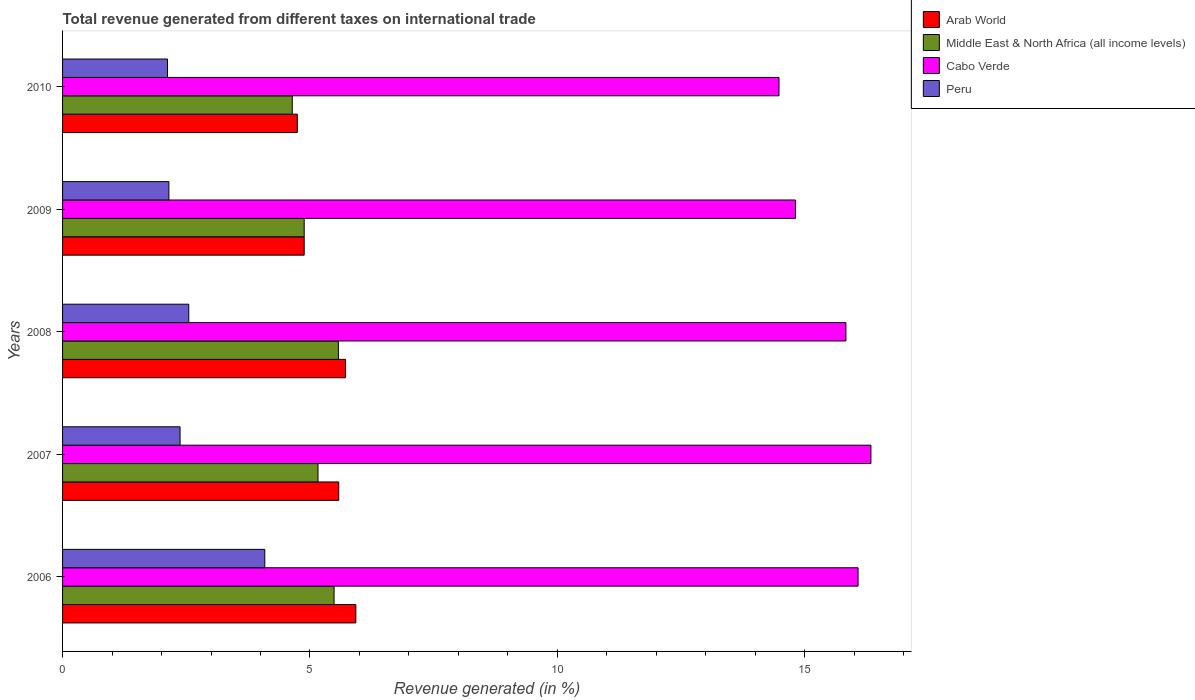Are the number of bars on each tick of the Y-axis equal?
Make the answer very short. Yes. How many bars are there on the 1st tick from the top?
Give a very brief answer. 4. In how many cases, is the number of bars for a given year not equal to the number of legend labels?
Offer a very short reply. 0. What is the total revenue generated in Middle East & North Africa (all income levels) in 2009?
Your response must be concise. 4.88. Across all years, what is the maximum total revenue generated in Arab World?
Your answer should be very brief. 5.93. Across all years, what is the minimum total revenue generated in Middle East & North Africa (all income levels)?
Your answer should be very brief. 4.64. What is the total total revenue generated in Arab World in the graph?
Your response must be concise. 26.86. What is the difference between the total revenue generated in Middle East & North Africa (all income levels) in 2006 and that in 2007?
Provide a succinct answer. 0.32. What is the difference between the total revenue generated in Arab World in 2006 and the total revenue generated in Cabo Verde in 2007?
Give a very brief answer. -10.41. What is the average total revenue generated in Middle East & North Africa (all income levels) per year?
Ensure brevity in your answer.  5.15. In the year 2008, what is the difference between the total revenue generated in Arab World and total revenue generated in Peru?
Offer a terse response. 3.17. In how many years, is the total revenue generated in Peru greater than 5 %?
Your answer should be very brief. 0. What is the ratio of the total revenue generated in Peru in 2006 to that in 2009?
Give a very brief answer. 1.9. Is the total revenue generated in Cabo Verde in 2006 less than that in 2008?
Offer a very short reply. No. What is the difference between the highest and the second highest total revenue generated in Middle East & North Africa (all income levels)?
Provide a short and direct response. 0.09. What is the difference between the highest and the lowest total revenue generated in Peru?
Ensure brevity in your answer.  1.97. In how many years, is the total revenue generated in Middle East & North Africa (all income levels) greater than the average total revenue generated in Middle East & North Africa (all income levels) taken over all years?
Give a very brief answer. 3. What does the 3rd bar from the top in 2007 represents?
Ensure brevity in your answer.  Middle East & North Africa (all income levels). What does the 4th bar from the bottom in 2009 represents?
Offer a terse response. Peru. How many bars are there?
Offer a terse response. 20. Are all the bars in the graph horizontal?
Give a very brief answer. Yes. What is the difference between two consecutive major ticks on the X-axis?
Ensure brevity in your answer.  5. Does the graph contain any zero values?
Offer a terse response. No. Where does the legend appear in the graph?
Your response must be concise. Top right. What is the title of the graph?
Ensure brevity in your answer.  Total revenue generated from different taxes on international trade. Does "Turkey" appear as one of the legend labels in the graph?
Keep it short and to the point. No. What is the label or title of the X-axis?
Provide a short and direct response. Revenue generated (in %). What is the label or title of the Y-axis?
Your answer should be compact. Years. What is the Revenue generated (in %) of Arab World in 2006?
Offer a terse response. 5.93. What is the Revenue generated (in %) of Middle East & North Africa (all income levels) in 2006?
Offer a terse response. 5.49. What is the Revenue generated (in %) of Cabo Verde in 2006?
Provide a succinct answer. 16.08. What is the Revenue generated (in %) of Peru in 2006?
Offer a very short reply. 4.09. What is the Revenue generated (in %) of Arab World in 2007?
Offer a very short reply. 5.58. What is the Revenue generated (in %) of Middle East & North Africa (all income levels) in 2007?
Your response must be concise. 5.16. What is the Revenue generated (in %) in Cabo Verde in 2007?
Provide a succinct answer. 16.34. What is the Revenue generated (in %) of Peru in 2007?
Your answer should be very brief. 2.37. What is the Revenue generated (in %) in Arab World in 2008?
Ensure brevity in your answer.  5.72. What is the Revenue generated (in %) in Middle East & North Africa (all income levels) in 2008?
Your answer should be compact. 5.58. What is the Revenue generated (in %) of Cabo Verde in 2008?
Your response must be concise. 15.83. What is the Revenue generated (in %) of Peru in 2008?
Provide a short and direct response. 2.55. What is the Revenue generated (in %) in Arab World in 2009?
Your answer should be compact. 4.88. What is the Revenue generated (in %) of Middle East & North Africa (all income levels) in 2009?
Provide a short and direct response. 4.88. What is the Revenue generated (in %) of Cabo Verde in 2009?
Provide a short and direct response. 14.81. What is the Revenue generated (in %) of Peru in 2009?
Make the answer very short. 2.15. What is the Revenue generated (in %) of Arab World in 2010?
Keep it short and to the point. 4.74. What is the Revenue generated (in %) in Middle East & North Africa (all income levels) in 2010?
Your answer should be very brief. 4.64. What is the Revenue generated (in %) of Cabo Verde in 2010?
Your response must be concise. 14.48. What is the Revenue generated (in %) of Peru in 2010?
Ensure brevity in your answer.  2.12. Across all years, what is the maximum Revenue generated (in %) of Arab World?
Provide a succinct answer. 5.93. Across all years, what is the maximum Revenue generated (in %) in Middle East & North Africa (all income levels)?
Provide a succinct answer. 5.58. Across all years, what is the maximum Revenue generated (in %) of Cabo Verde?
Keep it short and to the point. 16.34. Across all years, what is the maximum Revenue generated (in %) of Peru?
Provide a short and direct response. 4.09. Across all years, what is the minimum Revenue generated (in %) in Arab World?
Offer a very short reply. 4.74. Across all years, what is the minimum Revenue generated (in %) of Middle East & North Africa (all income levels)?
Provide a succinct answer. 4.64. Across all years, what is the minimum Revenue generated (in %) in Cabo Verde?
Give a very brief answer. 14.48. Across all years, what is the minimum Revenue generated (in %) in Peru?
Offer a very short reply. 2.12. What is the total Revenue generated (in %) in Arab World in the graph?
Provide a short and direct response. 26.86. What is the total Revenue generated (in %) in Middle East & North Africa (all income levels) in the graph?
Offer a very short reply. 25.75. What is the total Revenue generated (in %) of Cabo Verde in the graph?
Your response must be concise. 77.54. What is the total Revenue generated (in %) of Peru in the graph?
Keep it short and to the point. 13.28. What is the difference between the Revenue generated (in %) in Arab World in 2006 and that in 2007?
Your answer should be compact. 0.35. What is the difference between the Revenue generated (in %) of Middle East & North Africa (all income levels) in 2006 and that in 2007?
Keep it short and to the point. 0.32. What is the difference between the Revenue generated (in %) in Cabo Verde in 2006 and that in 2007?
Provide a succinct answer. -0.26. What is the difference between the Revenue generated (in %) in Peru in 2006 and that in 2007?
Make the answer very short. 1.71. What is the difference between the Revenue generated (in %) in Arab World in 2006 and that in 2008?
Offer a terse response. 0.21. What is the difference between the Revenue generated (in %) of Middle East & North Africa (all income levels) in 2006 and that in 2008?
Offer a very short reply. -0.09. What is the difference between the Revenue generated (in %) of Cabo Verde in 2006 and that in 2008?
Your answer should be very brief. 0.25. What is the difference between the Revenue generated (in %) in Peru in 2006 and that in 2008?
Offer a very short reply. 1.54. What is the difference between the Revenue generated (in %) of Arab World in 2006 and that in 2009?
Provide a short and direct response. 1.04. What is the difference between the Revenue generated (in %) of Middle East & North Africa (all income levels) in 2006 and that in 2009?
Ensure brevity in your answer.  0.6. What is the difference between the Revenue generated (in %) in Cabo Verde in 2006 and that in 2009?
Your response must be concise. 1.26. What is the difference between the Revenue generated (in %) of Peru in 2006 and that in 2009?
Your response must be concise. 1.94. What is the difference between the Revenue generated (in %) of Arab World in 2006 and that in 2010?
Ensure brevity in your answer.  1.18. What is the difference between the Revenue generated (in %) of Middle East & North Africa (all income levels) in 2006 and that in 2010?
Offer a very short reply. 0.84. What is the difference between the Revenue generated (in %) in Cabo Verde in 2006 and that in 2010?
Your answer should be very brief. 1.6. What is the difference between the Revenue generated (in %) of Peru in 2006 and that in 2010?
Provide a succinct answer. 1.97. What is the difference between the Revenue generated (in %) of Arab World in 2007 and that in 2008?
Your answer should be compact. -0.14. What is the difference between the Revenue generated (in %) in Middle East & North Africa (all income levels) in 2007 and that in 2008?
Offer a very short reply. -0.41. What is the difference between the Revenue generated (in %) of Cabo Verde in 2007 and that in 2008?
Offer a terse response. 0.51. What is the difference between the Revenue generated (in %) in Peru in 2007 and that in 2008?
Offer a very short reply. -0.18. What is the difference between the Revenue generated (in %) of Arab World in 2007 and that in 2009?
Your answer should be very brief. 0.7. What is the difference between the Revenue generated (in %) of Middle East & North Africa (all income levels) in 2007 and that in 2009?
Give a very brief answer. 0.28. What is the difference between the Revenue generated (in %) of Cabo Verde in 2007 and that in 2009?
Give a very brief answer. 1.52. What is the difference between the Revenue generated (in %) in Peru in 2007 and that in 2009?
Make the answer very short. 0.23. What is the difference between the Revenue generated (in %) in Arab World in 2007 and that in 2010?
Your answer should be very brief. 0.84. What is the difference between the Revenue generated (in %) in Middle East & North Africa (all income levels) in 2007 and that in 2010?
Give a very brief answer. 0.52. What is the difference between the Revenue generated (in %) in Cabo Verde in 2007 and that in 2010?
Give a very brief answer. 1.86. What is the difference between the Revenue generated (in %) in Peru in 2007 and that in 2010?
Ensure brevity in your answer.  0.25. What is the difference between the Revenue generated (in %) in Arab World in 2008 and that in 2009?
Ensure brevity in your answer.  0.84. What is the difference between the Revenue generated (in %) of Middle East & North Africa (all income levels) in 2008 and that in 2009?
Your answer should be very brief. 0.69. What is the difference between the Revenue generated (in %) in Cabo Verde in 2008 and that in 2009?
Provide a short and direct response. 1.02. What is the difference between the Revenue generated (in %) of Peru in 2008 and that in 2009?
Your response must be concise. 0.4. What is the difference between the Revenue generated (in %) of Arab World in 2008 and that in 2010?
Your answer should be very brief. 0.97. What is the difference between the Revenue generated (in %) of Middle East & North Africa (all income levels) in 2008 and that in 2010?
Give a very brief answer. 0.93. What is the difference between the Revenue generated (in %) in Cabo Verde in 2008 and that in 2010?
Provide a short and direct response. 1.35. What is the difference between the Revenue generated (in %) of Peru in 2008 and that in 2010?
Keep it short and to the point. 0.43. What is the difference between the Revenue generated (in %) of Arab World in 2009 and that in 2010?
Provide a short and direct response. 0.14. What is the difference between the Revenue generated (in %) in Middle East & North Africa (all income levels) in 2009 and that in 2010?
Ensure brevity in your answer.  0.24. What is the difference between the Revenue generated (in %) in Cabo Verde in 2009 and that in 2010?
Give a very brief answer. 0.33. What is the difference between the Revenue generated (in %) of Peru in 2009 and that in 2010?
Provide a succinct answer. 0.03. What is the difference between the Revenue generated (in %) in Arab World in 2006 and the Revenue generated (in %) in Middle East & North Africa (all income levels) in 2007?
Provide a short and direct response. 0.77. What is the difference between the Revenue generated (in %) in Arab World in 2006 and the Revenue generated (in %) in Cabo Verde in 2007?
Make the answer very short. -10.41. What is the difference between the Revenue generated (in %) in Arab World in 2006 and the Revenue generated (in %) in Peru in 2007?
Keep it short and to the point. 3.55. What is the difference between the Revenue generated (in %) in Middle East & North Africa (all income levels) in 2006 and the Revenue generated (in %) in Cabo Verde in 2007?
Give a very brief answer. -10.85. What is the difference between the Revenue generated (in %) of Middle East & North Africa (all income levels) in 2006 and the Revenue generated (in %) of Peru in 2007?
Your answer should be very brief. 3.11. What is the difference between the Revenue generated (in %) of Cabo Verde in 2006 and the Revenue generated (in %) of Peru in 2007?
Your response must be concise. 13.7. What is the difference between the Revenue generated (in %) in Arab World in 2006 and the Revenue generated (in %) in Middle East & North Africa (all income levels) in 2008?
Your answer should be compact. 0.35. What is the difference between the Revenue generated (in %) of Arab World in 2006 and the Revenue generated (in %) of Cabo Verde in 2008?
Give a very brief answer. -9.9. What is the difference between the Revenue generated (in %) in Arab World in 2006 and the Revenue generated (in %) in Peru in 2008?
Offer a terse response. 3.38. What is the difference between the Revenue generated (in %) of Middle East & North Africa (all income levels) in 2006 and the Revenue generated (in %) of Cabo Verde in 2008?
Your answer should be compact. -10.35. What is the difference between the Revenue generated (in %) in Middle East & North Africa (all income levels) in 2006 and the Revenue generated (in %) in Peru in 2008?
Provide a short and direct response. 2.94. What is the difference between the Revenue generated (in %) in Cabo Verde in 2006 and the Revenue generated (in %) in Peru in 2008?
Your response must be concise. 13.53. What is the difference between the Revenue generated (in %) of Arab World in 2006 and the Revenue generated (in %) of Middle East & North Africa (all income levels) in 2009?
Your answer should be compact. 1.04. What is the difference between the Revenue generated (in %) in Arab World in 2006 and the Revenue generated (in %) in Cabo Verde in 2009?
Your answer should be very brief. -8.89. What is the difference between the Revenue generated (in %) of Arab World in 2006 and the Revenue generated (in %) of Peru in 2009?
Offer a terse response. 3.78. What is the difference between the Revenue generated (in %) in Middle East & North Africa (all income levels) in 2006 and the Revenue generated (in %) in Cabo Verde in 2009?
Your response must be concise. -9.33. What is the difference between the Revenue generated (in %) of Middle East & North Africa (all income levels) in 2006 and the Revenue generated (in %) of Peru in 2009?
Make the answer very short. 3.34. What is the difference between the Revenue generated (in %) of Cabo Verde in 2006 and the Revenue generated (in %) of Peru in 2009?
Make the answer very short. 13.93. What is the difference between the Revenue generated (in %) of Arab World in 2006 and the Revenue generated (in %) of Middle East & North Africa (all income levels) in 2010?
Ensure brevity in your answer.  1.28. What is the difference between the Revenue generated (in %) in Arab World in 2006 and the Revenue generated (in %) in Cabo Verde in 2010?
Your answer should be very brief. -8.55. What is the difference between the Revenue generated (in %) in Arab World in 2006 and the Revenue generated (in %) in Peru in 2010?
Keep it short and to the point. 3.81. What is the difference between the Revenue generated (in %) of Middle East & North Africa (all income levels) in 2006 and the Revenue generated (in %) of Cabo Verde in 2010?
Provide a succinct answer. -8.99. What is the difference between the Revenue generated (in %) in Middle East & North Africa (all income levels) in 2006 and the Revenue generated (in %) in Peru in 2010?
Give a very brief answer. 3.37. What is the difference between the Revenue generated (in %) of Cabo Verde in 2006 and the Revenue generated (in %) of Peru in 2010?
Offer a very short reply. 13.96. What is the difference between the Revenue generated (in %) in Arab World in 2007 and the Revenue generated (in %) in Middle East & North Africa (all income levels) in 2008?
Your answer should be very brief. 0.01. What is the difference between the Revenue generated (in %) of Arab World in 2007 and the Revenue generated (in %) of Cabo Verde in 2008?
Provide a succinct answer. -10.25. What is the difference between the Revenue generated (in %) of Arab World in 2007 and the Revenue generated (in %) of Peru in 2008?
Your answer should be compact. 3.03. What is the difference between the Revenue generated (in %) in Middle East & North Africa (all income levels) in 2007 and the Revenue generated (in %) in Cabo Verde in 2008?
Offer a very short reply. -10.67. What is the difference between the Revenue generated (in %) of Middle East & North Africa (all income levels) in 2007 and the Revenue generated (in %) of Peru in 2008?
Your response must be concise. 2.61. What is the difference between the Revenue generated (in %) in Cabo Verde in 2007 and the Revenue generated (in %) in Peru in 2008?
Give a very brief answer. 13.79. What is the difference between the Revenue generated (in %) of Arab World in 2007 and the Revenue generated (in %) of Middle East & North Africa (all income levels) in 2009?
Offer a terse response. 0.7. What is the difference between the Revenue generated (in %) in Arab World in 2007 and the Revenue generated (in %) in Cabo Verde in 2009?
Your answer should be compact. -9.23. What is the difference between the Revenue generated (in %) of Arab World in 2007 and the Revenue generated (in %) of Peru in 2009?
Your answer should be compact. 3.43. What is the difference between the Revenue generated (in %) of Middle East & North Africa (all income levels) in 2007 and the Revenue generated (in %) of Cabo Verde in 2009?
Give a very brief answer. -9.65. What is the difference between the Revenue generated (in %) of Middle East & North Africa (all income levels) in 2007 and the Revenue generated (in %) of Peru in 2009?
Your answer should be very brief. 3.01. What is the difference between the Revenue generated (in %) of Cabo Verde in 2007 and the Revenue generated (in %) of Peru in 2009?
Your response must be concise. 14.19. What is the difference between the Revenue generated (in %) in Arab World in 2007 and the Revenue generated (in %) in Middle East & North Africa (all income levels) in 2010?
Provide a short and direct response. 0.94. What is the difference between the Revenue generated (in %) of Arab World in 2007 and the Revenue generated (in %) of Cabo Verde in 2010?
Provide a succinct answer. -8.9. What is the difference between the Revenue generated (in %) of Arab World in 2007 and the Revenue generated (in %) of Peru in 2010?
Offer a very short reply. 3.46. What is the difference between the Revenue generated (in %) of Middle East & North Africa (all income levels) in 2007 and the Revenue generated (in %) of Cabo Verde in 2010?
Make the answer very short. -9.32. What is the difference between the Revenue generated (in %) of Middle East & North Africa (all income levels) in 2007 and the Revenue generated (in %) of Peru in 2010?
Make the answer very short. 3.04. What is the difference between the Revenue generated (in %) in Cabo Verde in 2007 and the Revenue generated (in %) in Peru in 2010?
Ensure brevity in your answer.  14.22. What is the difference between the Revenue generated (in %) of Arab World in 2008 and the Revenue generated (in %) of Middle East & North Africa (all income levels) in 2009?
Make the answer very short. 0.84. What is the difference between the Revenue generated (in %) in Arab World in 2008 and the Revenue generated (in %) in Cabo Verde in 2009?
Your answer should be compact. -9.09. What is the difference between the Revenue generated (in %) in Arab World in 2008 and the Revenue generated (in %) in Peru in 2009?
Your answer should be very brief. 3.57. What is the difference between the Revenue generated (in %) of Middle East & North Africa (all income levels) in 2008 and the Revenue generated (in %) of Cabo Verde in 2009?
Your answer should be very brief. -9.24. What is the difference between the Revenue generated (in %) in Middle East & North Africa (all income levels) in 2008 and the Revenue generated (in %) in Peru in 2009?
Your answer should be compact. 3.43. What is the difference between the Revenue generated (in %) in Cabo Verde in 2008 and the Revenue generated (in %) in Peru in 2009?
Provide a short and direct response. 13.68. What is the difference between the Revenue generated (in %) of Arab World in 2008 and the Revenue generated (in %) of Middle East & North Africa (all income levels) in 2010?
Your response must be concise. 1.08. What is the difference between the Revenue generated (in %) of Arab World in 2008 and the Revenue generated (in %) of Cabo Verde in 2010?
Your response must be concise. -8.76. What is the difference between the Revenue generated (in %) in Arab World in 2008 and the Revenue generated (in %) in Peru in 2010?
Make the answer very short. 3.6. What is the difference between the Revenue generated (in %) in Middle East & North Africa (all income levels) in 2008 and the Revenue generated (in %) in Cabo Verde in 2010?
Ensure brevity in your answer.  -8.9. What is the difference between the Revenue generated (in %) in Middle East & North Africa (all income levels) in 2008 and the Revenue generated (in %) in Peru in 2010?
Ensure brevity in your answer.  3.45. What is the difference between the Revenue generated (in %) in Cabo Verde in 2008 and the Revenue generated (in %) in Peru in 2010?
Ensure brevity in your answer.  13.71. What is the difference between the Revenue generated (in %) in Arab World in 2009 and the Revenue generated (in %) in Middle East & North Africa (all income levels) in 2010?
Provide a succinct answer. 0.24. What is the difference between the Revenue generated (in %) in Arab World in 2009 and the Revenue generated (in %) in Cabo Verde in 2010?
Provide a short and direct response. -9.6. What is the difference between the Revenue generated (in %) in Arab World in 2009 and the Revenue generated (in %) in Peru in 2010?
Offer a very short reply. 2.76. What is the difference between the Revenue generated (in %) of Middle East & North Africa (all income levels) in 2009 and the Revenue generated (in %) of Cabo Verde in 2010?
Offer a terse response. -9.6. What is the difference between the Revenue generated (in %) in Middle East & North Africa (all income levels) in 2009 and the Revenue generated (in %) in Peru in 2010?
Make the answer very short. 2.76. What is the difference between the Revenue generated (in %) of Cabo Verde in 2009 and the Revenue generated (in %) of Peru in 2010?
Ensure brevity in your answer.  12.69. What is the average Revenue generated (in %) of Arab World per year?
Ensure brevity in your answer.  5.37. What is the average Revenue generated (in %) of Middle East & North Africa (all income levels) per year?
Your answer should be compact. 5.15. What is the average Revenue generated (in %) in Cabo Verde per year?
Provide a succinct answer. 15.51. What is the average Revenue generated (in %) in Peru per year?
Provide a short and direct response. 2.66. In the year 2006, what is the difference between the Revenue generated (in %) of Arab World and Revenue generated (in %) of Middle East & North Africa (all income levels)?
Your answer should be compact. 0.44. In the year 2006, what is the difference between the Revenue generated (in %) of Arab World and Revenue generated (in %) of Cabo Verde?
Your answer should be very brief. -10.15. In the year 2006, what is the difference between the Revenue generated (in %) in Arab World and Revenue generated (in %) in Peru?
Your response must be concise. 1.84. In the year 2006, what is the difference between the Revenue generated (in %) of Middle East & North Africa (all income levels) and Revenue generated (in %) of Cabo Verde?
Provide a short and direct response. -10.59. In the year 2006, what is the difference between the Revenue generated (in %) in Middle East & North Africa (all income levels) and Revenue generated (in %) in Peru?
Offer a very short reply. 1.4. In the year 2006, what is the difference between the Revenue generated (in %) of Cabo Verde and Revenue generated (in %) of Peru?
Keep it short and to the point. 11.99. In the year 2007, what is the difference between the Revenue generated (in %) of Arab World and Revenue generated (in %) of Middle East & North Africa (all income levels)?
Keep it short and to the point. 0.42. In the year 2007, what is the difference between the Revenue generated (in %) of Arab World and Revenue generated (in %) of Cabo Verde?
Offer a terse response. -10.76. In the year 2007, what is the difference between the Revenue generated (in %) in Arab World and Revenue generated (in %) in Peru?
Keep it short and to the point. 3.21. In the year 2007, what is the difference between the Revenue generated (in %) of Middle East & North Africa (all income levels) and Revenue generated (in %) of Cabo Verde?
Provide a short and direct response. -11.18. In the year 2007, what is the difference between the Revenue generated (in %) in Middle East & North Africa (all income levels) and Revenue generated (in %) in Peru?
Your answer should be compact. 2.79. In the year 2007, what is the difference between the Revenue generated (in %) in Cabo Verde and Revenue generated (in %) in Peru?
Provide a succinct answer. 13.96. In the year 2008, what is the difference between the Revenue generated (in %) in Arab World and Revenue generated (in %) in Middle East & North Africa (all income levels)?
Offer a very short reply. 0.14. In the year 2008, what is the difference between the Revenue generated (in %) of Arab World and Revenue generated (in %) of Cabo Verde?
Keep it short and to the point. -10.11. In the year 2008, what is the difference between the Revenue generated (in %) of Arab World and Revenue generated (in %) of Peru?
Provide a succinct answer. 3.17. In the year 2008, what is the difference between the Revenue generated (in %) of Middle East & North Africa (all income levels) and Revenue generated (in %) of Cabo Verde?
Keep it short and to the point. -10.26. In the year 2008, what is the difference between the Revenue generated (in %) in Middle East & North Africa (all income levels) and Revenue generated (in %) in Peru?
Give a very brief answer. 3.02. In the year 2008, what is the difference between the Revenue generated (in %) of Cabo Verde and Revenue generated (in %) of Peru?
Provide a short and direct response. 13.28. In the year 2009, what is the difference between the Revenue generated (in %) in Arab World and Revenue generated (in %) in Middle East & North Africa (all income levels)?
Give a very brief answer. 0. In the year 2009, what is the difference between the Revenue generated (in %) in Arab World and Revenue generated (in %) in Cabo Verde?
Offer a terse response. -9.93. In the year 2009, what is the difference between the Revenue generated (in %) in Arab World and Revenue generated (in %) in Peru?
Provide a short and direct response. 2.73. In the year 2009, what is the difference between the Revenue generated (in %) in Middle East & North Africa (all income levels) and Revenue generated (in %) in Cabo Verde?
Offer a very short reply. -9.93. In the year 2009, what is the difference between the Revenue generated (in %) in Middle East & North Africa (all income levels) and Revenue generated (in %) in Peru?
Your answer should be compact. 2.73. In the year 2009, what is the difference between the Revenue generated (in %) in Cabo Verde and Revenue generated (in %) in Peru?
Offer a very short reply. 12.67. In the year 2010, what is the difference between the Revenue generated (in %) in Arab World and Revenue generated (in %) in Middle East & North Africa (all income levels)?
Your response must be concise. 0.1. In the year 2010, what is the difference between the Revenue generated (in %) of Arab World and Revenue generated (in %) of Cabo Verde?
Your answer should be compact. -9.74. In the year 2010, what is the difference between the Revenue generated (in %) of Arab World and Revenue generated (in %) of Peru?
Provide a short and direct response. 2.62. In the year 2010, what is the difference between the Revenue generated (in %) in Middle East & North Africa (all income levels) and Revenue generated (in %) in Cabo Verde?
Ensure brevity in your answer.  -9.84. In the year 2010, what is the difference between the Revenue generated (in %) of Middle East & North Africa (all income levels) and Revenue generated (in %) of Peru?
Give a very brief answer. 2.52. In the year 2010, what is the difference between the Revenue generated (in %) in Cabo Verde and Revenue generated (in %) in Peru?
Provide a short and direct response. 12.36. What is the ratio of the Revenue generated (in %) in Arab World in 2006 to that in 2007?
Your answer should be compact. 1.06. What is the ratio of the Revenue generated (in %) of Middle East & North Africa (all income levels) in 2006 to that in 2007?
Make the answer very short. 1.06. What is the ratio of the Revenue generated (in %) of Cabo Verde in 2006 to that in 2007?
Your answer should be very brief. 0.98. What is the ratio of the Revenue generated (in %) in Peru in 2006 to that in 2007?
Your response must be concise. 1.72. What is the ratio of the Revenue generated (in %) in Arab World in 2006 to that in 2008?
Provide a succinct answer. 1.04. What is the ratio of the Revenue generated (in %) in Middle East & North Africa (all income levels) in 2006 to that in 2008?
Ensure brevity in your answer.  0.98. What is the ratio of the Revenue generated (in %) of Cabo Verde in 2006 to that in 2008?
Provide a short and direct response. 1.02. What is the ratio of the Revenue generated (in %) of Peru in 2006 to that in 2008?
Offer a very short reply. 1.6. What is the ratio of the Revenue generated (in %) of Arab World in 2006 to that in 2009?
Provide a succinct answer. 1.21. What is the ratio of the Revenue generated (in %) in Middle East & North Africa (all income levels) in 2006 to that in 2009?
Give a very brief answer. 1.12. What is the ratio of the Revenue generated (in %) of Cabo Verde in 2006 to that in 2009?
Offer a terse response. 1.09. What is the ratio of the Revenue generated (in %) in Peru in 2006 to that in 2009?
Make the answer very short. 1.9. What is the ratio of the Revenue generated (in %) of Arab World in 2006 to that in 2010?
Offer a very short reply. 1.25. What is the ratio of the Revenue generated (in %) in Middle East & North Africa (all income levels) in 2006 to that in 2010?
Provide a short and direct response. 1.18. What is the ratio of the Revenue generated (in %) of Cabo Verde in 2006 to that in 2010?
Your response must be concise. 1.11. What is the ratio of the Revenue generated (in %) in Peru in 2006 to that in 2010?
Offer a terse response. 1.93. What is the ratio of the Revenue generated (in %) of Arab World in 2007 to that in 2008?
Your response must be concise. 0.98. What is the ratio of the Revenue generated (in %) in Middle East & North Africa (all income levels) in 2007 to that in 2008?
Offer a terse response. 0.93. What is the ratio of the Revenue generated (in %) in Cabo Verde in 2007 to that in 2008?
Ensure brevity in your answer.  1.03. What is the ratio of the Revenue generated (in %) of Peru in 2007 to that in 2008?
Give a very brief answer. 0.93. What is the ratio of the Revenue generated (in %) in Arab World in 2007 to that in 2009?
Provide a succinct answer. 1.14. What is the ratio of the Revenue generated (in %) in Middle East & North Africa (all income levels) in 2007 to that in 2009?
Your response must be concise. 1.06. What is the ratio of the Revenue generated (in %) in Cabo Verde in 2007 to that in 2009?
Give a very brief answer. 1.1. What is the ratio of the Revenue generated (in %) in Peru in 2007 to that in 2009?
Make the answer very short. 1.11. What is the ratio of the Revenue generated (in %) of Arab World in 2007 to that in 2010?
Make the answer very short. 1.18. What is the ratio of the Revenue generated (in %) of Middle East & North Africa (all income levels) in 2007 to that in 2010?
Offer a very short reply. 1.11. What is the ratio of the Revenue generated (in %) of Cabo Verde in 2007 to that in 2010?
Keep it short and to the point. 1.13. What is the ratio of the Revenue generated (in %) in Peru in 2007 to that in 2010?
Provide a succinct answer. 1.12. What is the ratio of the Revenue generated (in %) of Arab World in 2008 to that in 2009?
Provide a succinct answer. 1.17. What is the ratio of the Revenue generated (in %) of Middle East & North Africa (all income levels) in 2008 to that in 2009?
Offer a terse response. 1.14. What is the ratio of the Revenue generated (in %) of Cabo Verde in 2008 to that in 2009?
Offer a terse response. 1.07. What is the ratio of the Revenue generated (in %) of Peru in 2008 to that in 2009?
Provide a succinct answer. 1.19. What is the ratio of the Revenue generated (in %) of Arab World in 2008 to that in 2010?
Offer a very short reply. 1.21. What is the ratio of the Revenue generated (in %) of Middle East & North Africa (all income levels) in 2008 to that in 2010?
Provide a short and direct response. 1.2. What is the ratio of the Revenue generated (in %) in Cabo Verde in 2008 to that in 2010?
Your answer should be very brief. 1.09. What is the ratio of the Revenue generated (in %) in Peru in 2008 to that in 2010?
Make the answer very short. 1.2. What is the ratio of the Revenue generated (in %) in Arab World in 2009 to that in 2010?
Ensure brevity in your answer.  1.03. What is the ratio of the Revenue generated (in %) in Middle East & North Africa (all income levels) in 2009 to that in 2010?
Offer a very short reply. 1.05. What is the ratio of the Revenue generated (in %) in Cabo Verde in 2009 to that in 2010?
Keep it short and to the point. 1.02. What is the ratio of the Revenue generated (in %) in Peru in 2009 to that in 2010?
Make the answer very short. 1.01. What is the difference between the highest and the second highest Revenue generated (in %) of Arab World?
Provide a succinct answer. 0.21. What is the difference between the highest and the second highest Revenue generated (in %) in Middle East & North Africa (all income levels)?
Offer a very short reply. 0.09. What is the difference between the highest and the second highest Revenue generated (in %) of Cabo Verde?
Your answer should be compact. 0.26. What is the difference between the highest and the second highest Revenue generated (in %) in Peru?
Offer a very short reply. 1.54. What is the difference between the highest and the lowest Revenue generated (in %) of Arab World?
Make the answer very short. 1.18. What is the difference between the highest and the lowest Revenue generated (in %) of Middle East & North Africa (all income levels)?
Provide a succinct answer. 0.93. What is the difference between the highest and the lowest Revenue generated (in %) of Cabo Verde?
Offer a very short reply. 1.86. What is the difference between the highest and the lowest Revenue generated (in %) of Peru?
Give a very brief answer. 1.97. 